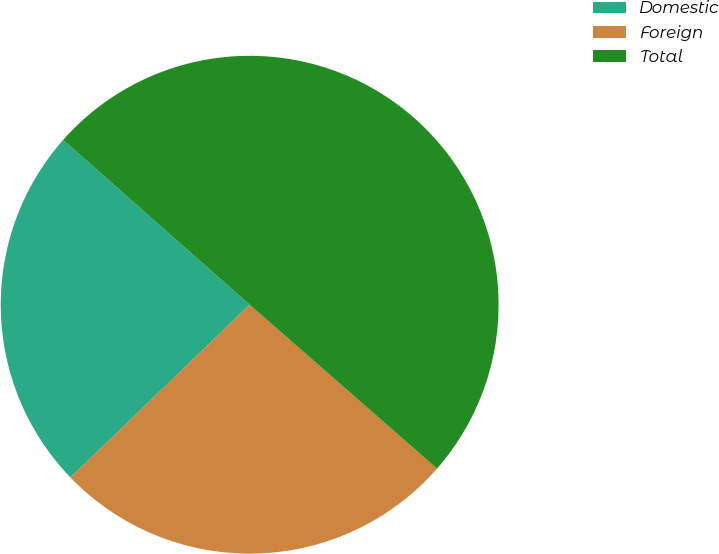Convert chart. <chart><loc_0><loc_0><loc_500><loc_500><pie_chart><fcel>Domestic<fcel>Foreign<fcel>Total<nl><fcel>23.73%<fcel>26.35%<fcel>49.92%<nl></chart> 